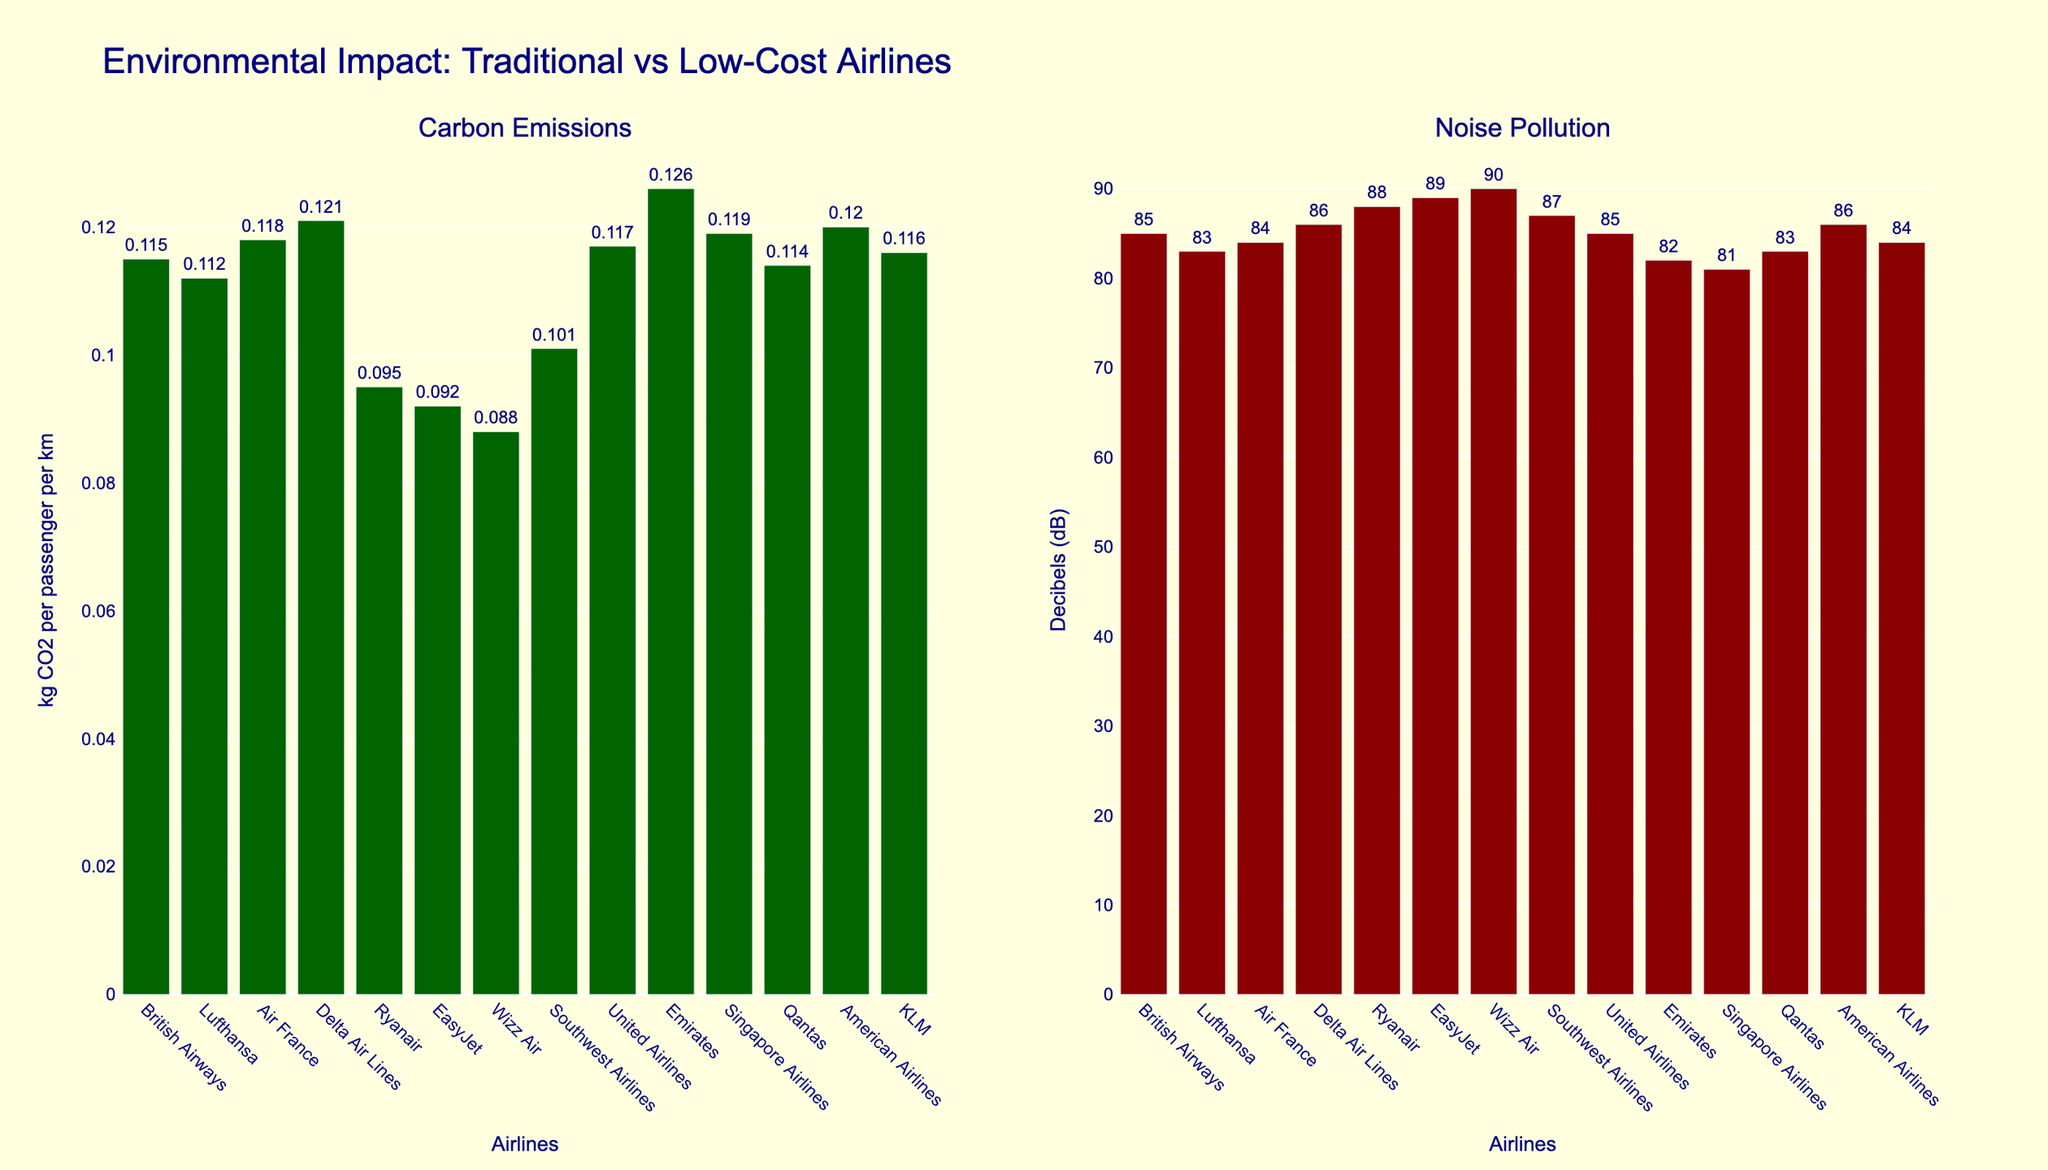Which airline has the highest carbon emissions? By examining the height of the bars in the "Carbon Emissions" subplot, the highest bar represents Emirates at 0.126 kg CO2 per passenger per km
Answer: Emirates Which airline has the lowest noise pollution at takeoff? By checking the height of the bars in the "Noise Pollution" subplot, the shortest bar is for Singapore Airlines at 81 dB
Answer: Singapore Airlines What is the difference in carbon emissions between British Airways and Ryanair? British Airways emits 0.115 kg CO2 per passenger per km, and Ryanair emits 0.095 kg CO2 per passenger per km. The difference is 0.115 - 0.095 = 0.02
Answer: 0.02 Which low-cost airline has the lowest carbon emissions? Among Ryanair, EasyJet, and Wizz Air, the shortest bar in the "Carbon Emissions" subplot is for Wizz Air at 0.088 kg CO2 per passenger per km
Answer: Wizz Air How much higher is EasyJet's noise pollution compared to KLM's? EasyJet has a noise pollution of 89 dB, while KLM has 84 dB. The difference is 89 - 84 = 5
Answer: 5 Which airline has both lower carbon emissions and higher noise pollution compared to British Airways? British Airways has 0.115 kg CO2 per passenger per km and 85 dB. Ryanair, EasyJet, Wizz Air, Southwest Airlines all have lower carbon emissions and higher noise pollution; the closest match is EasyJet
Answer: EasyJet What is the average carbon emission for traditional airlines like British Airways, Lufthansa, Air France, Delta Air Lines, United Airlines, Emirates, Singapore Airlines, Qantas, and American Airlines? Sum their carbon emissions: 0.115 + 0.112 + 0.118 + 0.121 + 0.117 + 0.126 + 0.119 + 0.114 + 0.120 = 1.062. Number of airlines = 9. Average = 1.062 / 9 = 0.118
Answer: 0.118 Compare the noise pollution of traditional airlines to that of low-cost airlines. In general, do low-cost airlines have higher noise pollution? By visually comparing bars in the "Noise Pollution" subplot, traditional airlines generally show values around 81-86 dB while low-cost airlines display values from 88-90 dB. On average, low-cost airlines have higher noise pollution
Answer: Yes Which airline has the lowest carbon emissions among traditional, non-low-cost airlines? Among traditional airlines, the shortest bar in "Carbon Emissions" subplot is Lufthansa at 0.112 kg CO2 per passenger per km
Answer: Lufthansa 